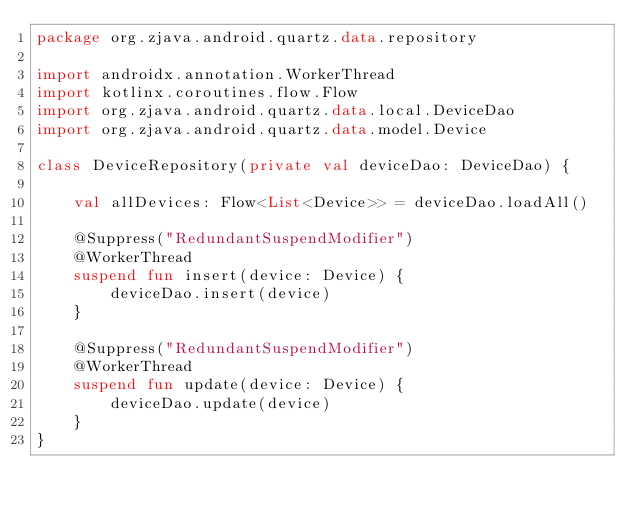Convert code to text. <code><loc_0><loc_0><loc_500><loc_500><_Kotlin_>package org.zjava.android.quartz.data.repository

import androidx.annotation.WorkerThread
import kotlinx.coroutines.flow.Flow
import org.zjava.android.quartz.data.local.DeviceDao
import org.zjava.android.quartz.data.model.Device

class DeviceRepository(private val deviceDao: DeviceDao) {

    val allDevices: Flow<List<Device>> = deviceDao.loadAll()

    @Suppress("RedundantSuspendModifier")
    @WorkerThread
    suspend fun insert(device: Device) {
        deviceDao.insert(device)
    }

    @Suppress("RedundantSuspendModifier")
    @WorkerThread
    suspend fun update(device: Device) {
        deviceDao.update(device)
    }
}</code> 